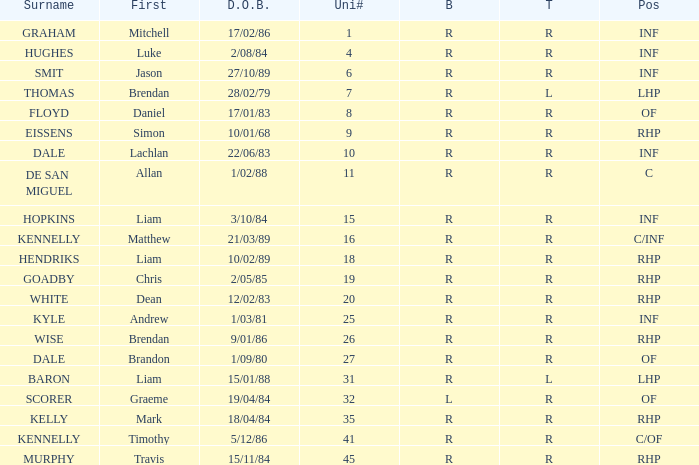Which batter has the last name Graham? R. 